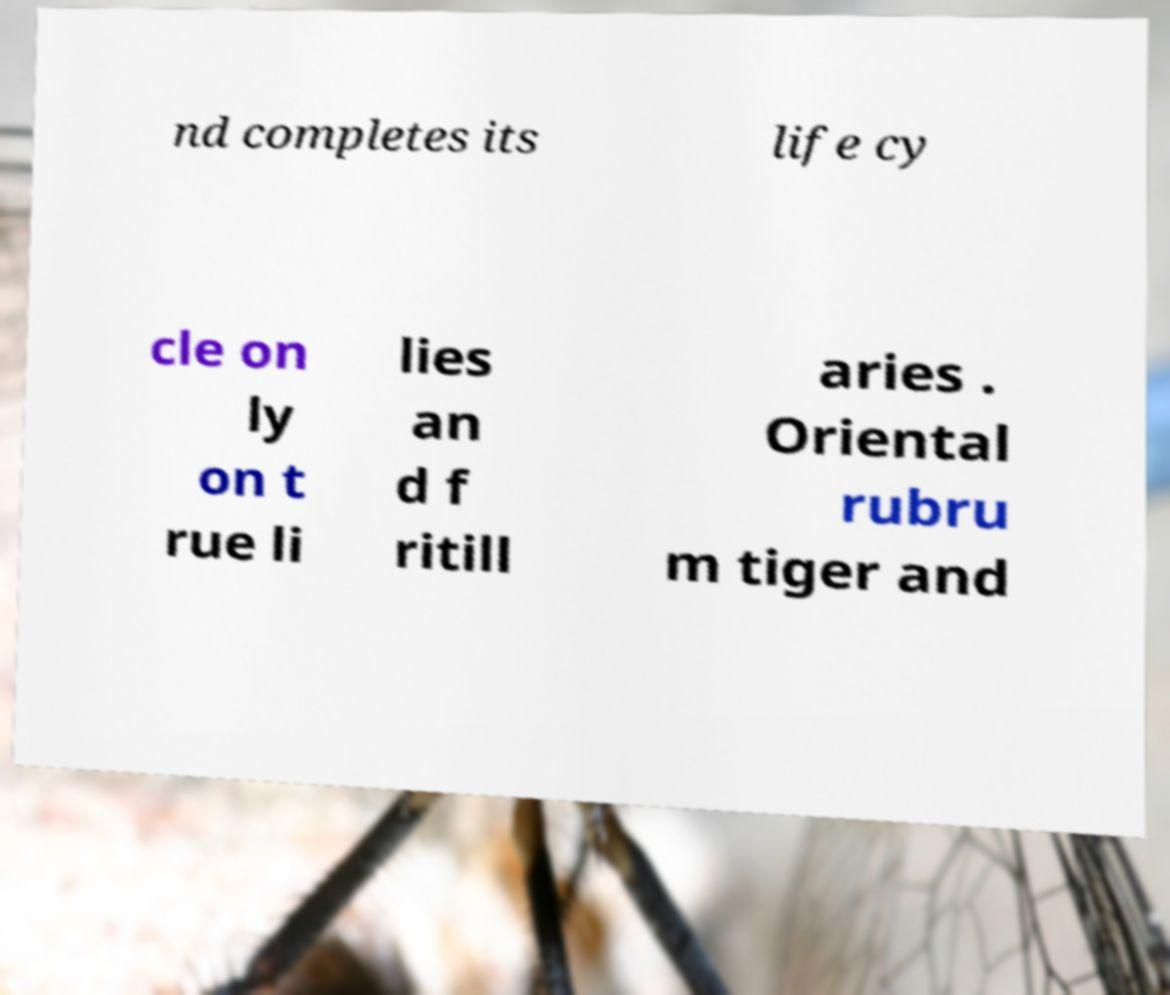For documentation purposes, I need the text within this image transcribed. Could you provide that? nd completes its life cy cle on ly on t rue li lies an d f ritill aries . Oriental rubru m tiger and 